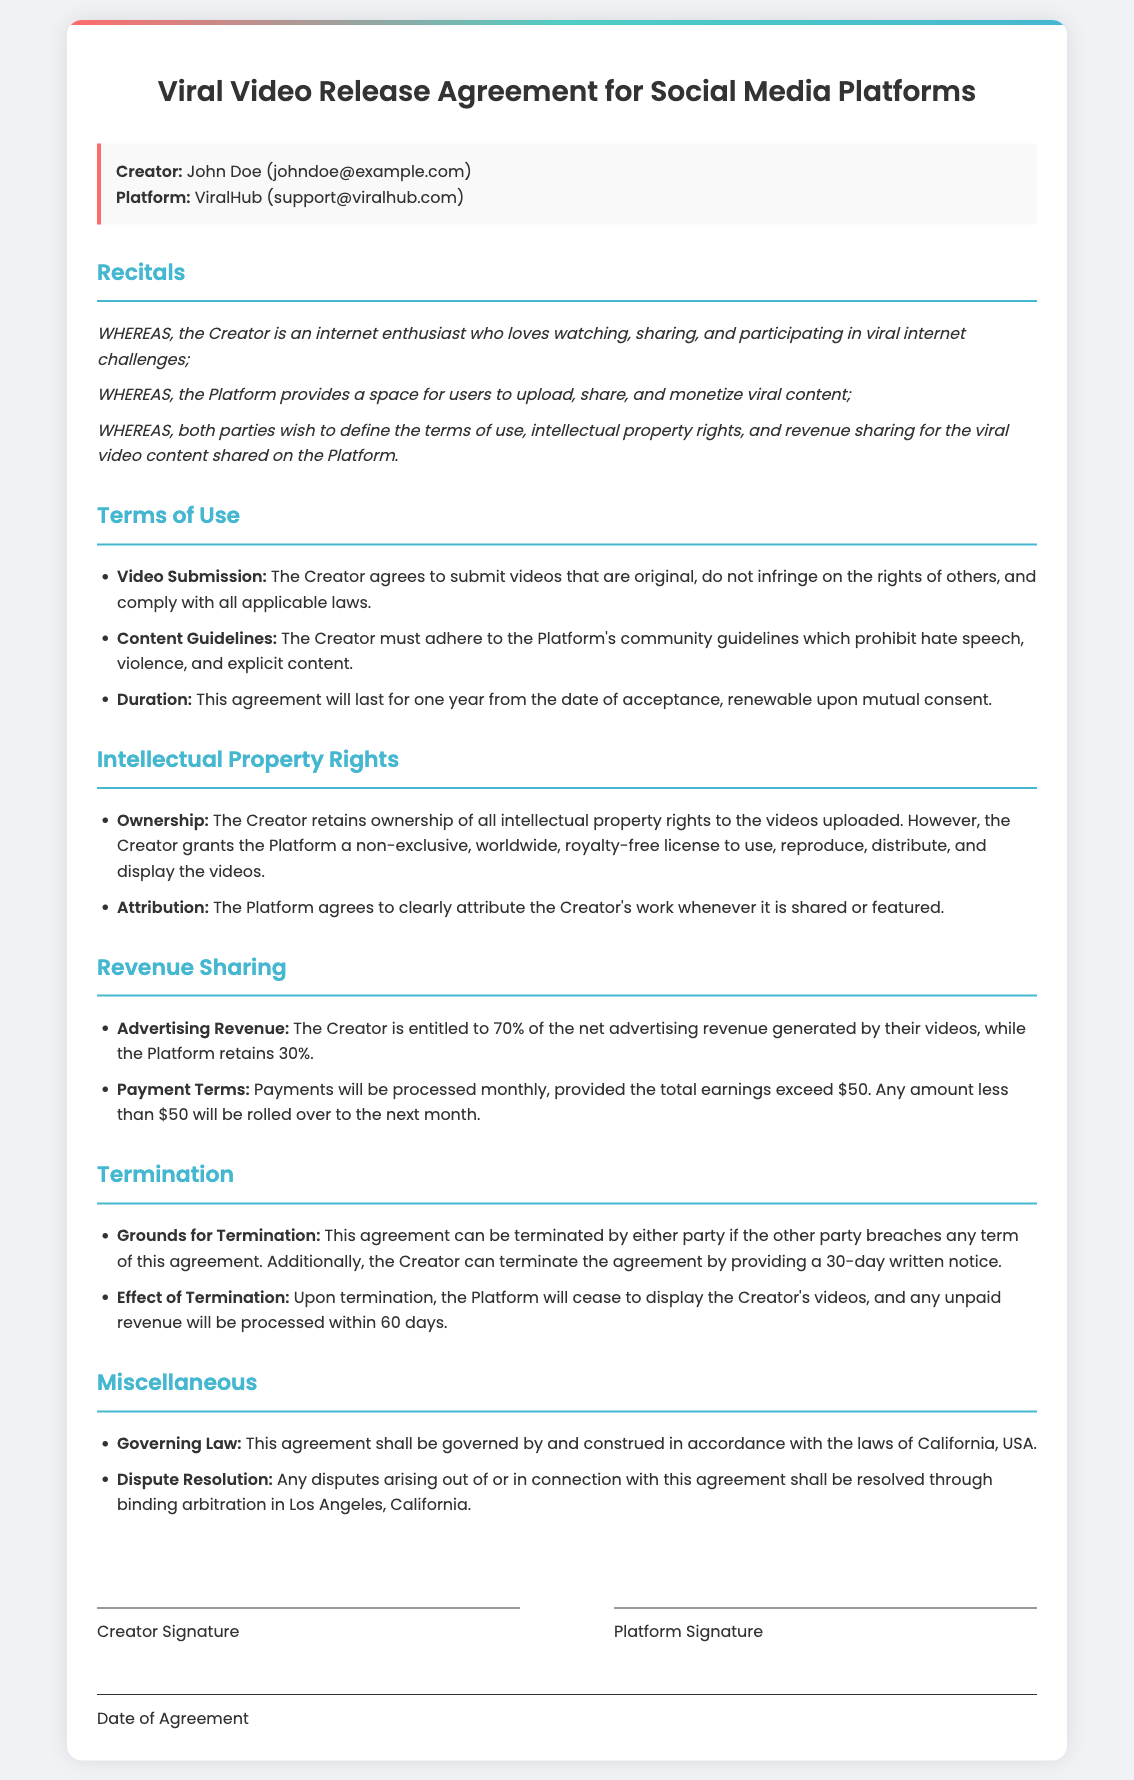What is the name of the creator? The creator's name is explicitly stated at the beginning of the document.
Answer: John Doe What is the creator's email? The creator's email is provided in the introduction of the agreement.
Answer: johndoe@example.com What percentage of advertising revenue does the creator receive? The revenue sharing section states the percentage allotted to the creator.
Answer: 70% What is the minimum earnings for payment processing? The payment terms section mentions the threshold for processing earnings.
Answer: $50 How long is the duration of the agreement? The terms of use section specifies the length of the agreement.
Answer: One year What is the governing law for the agreement? The miscellaneous section identifies the governing law applicable to the document.
Answer: California What should the platform do to attribute the creator's work? The document mentions what the platform must do regarding attribution.
Answer: Clearly attribute What is the notice period to terminate the agreement? The termination section outlines the notice period required for termination.
Answer: 30 days Where will disputes be resolved? The dispute resolution section specifies the location for resolving disputes.
Answer: Los Angeles, California 